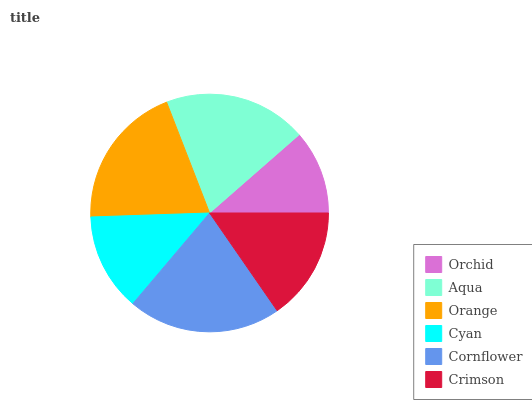Is Orchid the minimum?
Answer yes or no. Yes. Is Cornflower the maximum?
Answer yes or no. Yes. Is Aqua the minimum?
Answer yes or no. No. Is Aqua the maximum?
Answer yes or no. No. Is Aqua greater than Orchid?
Answer yes or no. Yes. Is Orchid less than Aqua?
Answer yes or no. Yes. Is Orchid greater than Aqua?
Answer yes or no. No. Is Aqua less than Orchid?
Answer yes or no. No. Is Aqua the high median?
Answer yes or no. Yes. Is Crimson the low median?
Answer yes or no. Yes. Is Cyan the high median?
Answer yes or no. No. Is Cyan the low median?
Answer yes or no. No. 